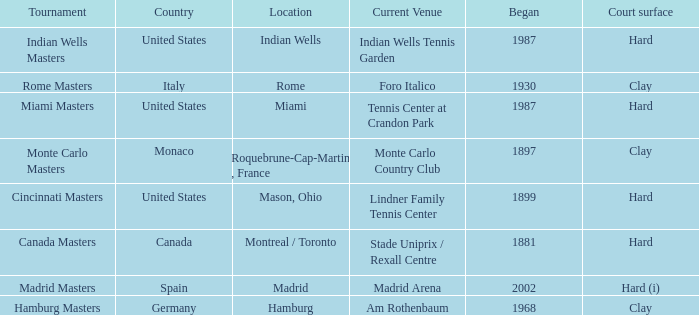What year was the tournament first held in Italy? 1930.0. 